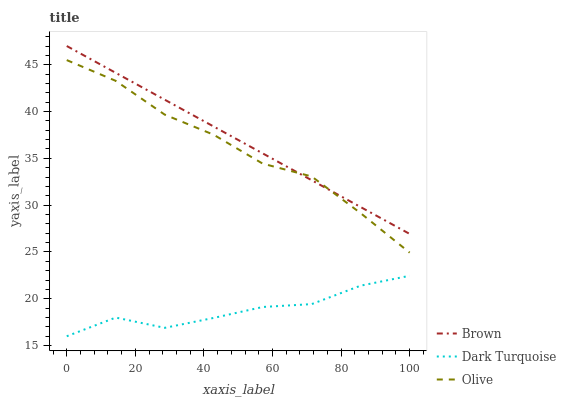Does Dark Turquoise have the minimum area under the curve?
Answer yes or no. Yes. Does Brown have the maximum area under the curve?
Answer yes or no. Yes. Does Brown have the minimum area under the curve?
Answer yes or no. No. Does Dark Turquoise have the maximum area under the curve?
Answer yes or no. No. Is Brown the smoothest?
Answer yes or no. Yes. Is Dark Turquoise the roughest?
Answer yes or no. Yes. Is Dark Turquoise the smoothest?
Answer yes or no. No. Is Brown the roughest?
Answer yes or no. No. Does Dark Turquoise have the lowest value?
Answer yes or no. Yes. Does Brown have the lowest value?
Answer yes or no. No. Does Brown have the highest value?
Answer yes or no. Yes. Does Dark Turquoise have the highest value?
Answer yes or no. No. Is Dark Turquoise less than Olive?
Answer yes or no. Yes. Is Brown greater than Dark Turquoise?
Answer yes or no. Yes. Does Brown intersect Olive?
Answer yes or no. Yes. Is Brown less than Olive?
Answer yes or no. No. Is Brown greater than Olive?
Answer yes or no. No. Does Dark Turquoise intersect Olive?
Answer yes or no. No. 